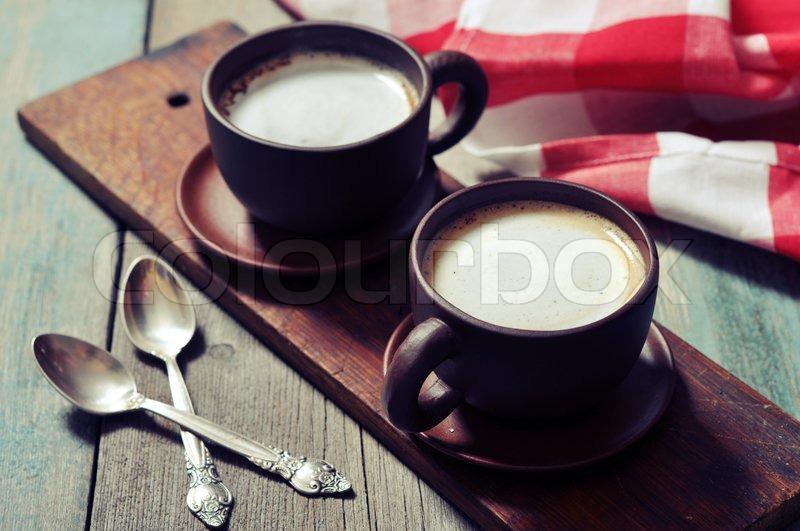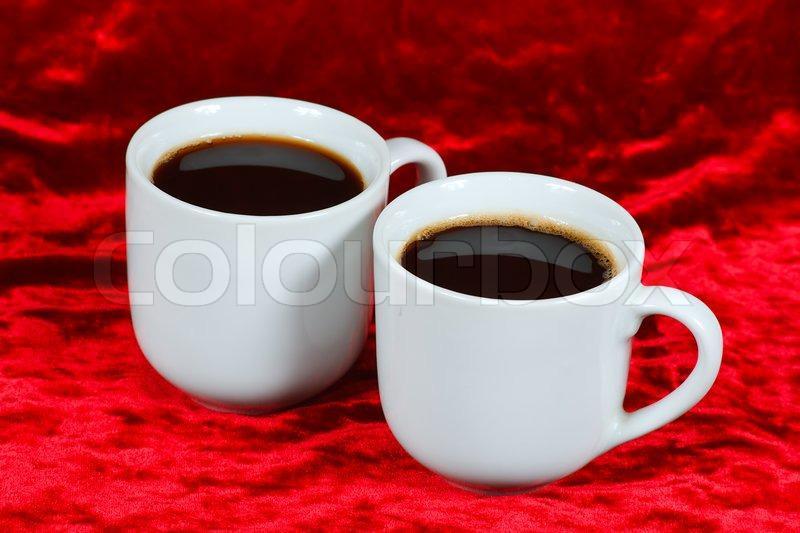The first image is the image on the left, the second image is the image on the right. Considering the images on both sides, is "At least one image shows a pair of filled cups with silver spoons nearby." valid? Answer yes or no. Yes. The first image is the image on the left, the second image is the image on the right. Evaluate the accuracy of this statement regarding the images: "The left image features two spoons and two beverages in cups.". Is it true? Answer yes or no. Yes. The first image is the image on the left, the second image is the image on the right. Evaluate the accuracy of this statement regarding the images: "Two spoons are visible in the left image.". Is it true? Answer yes or no. Yes. 